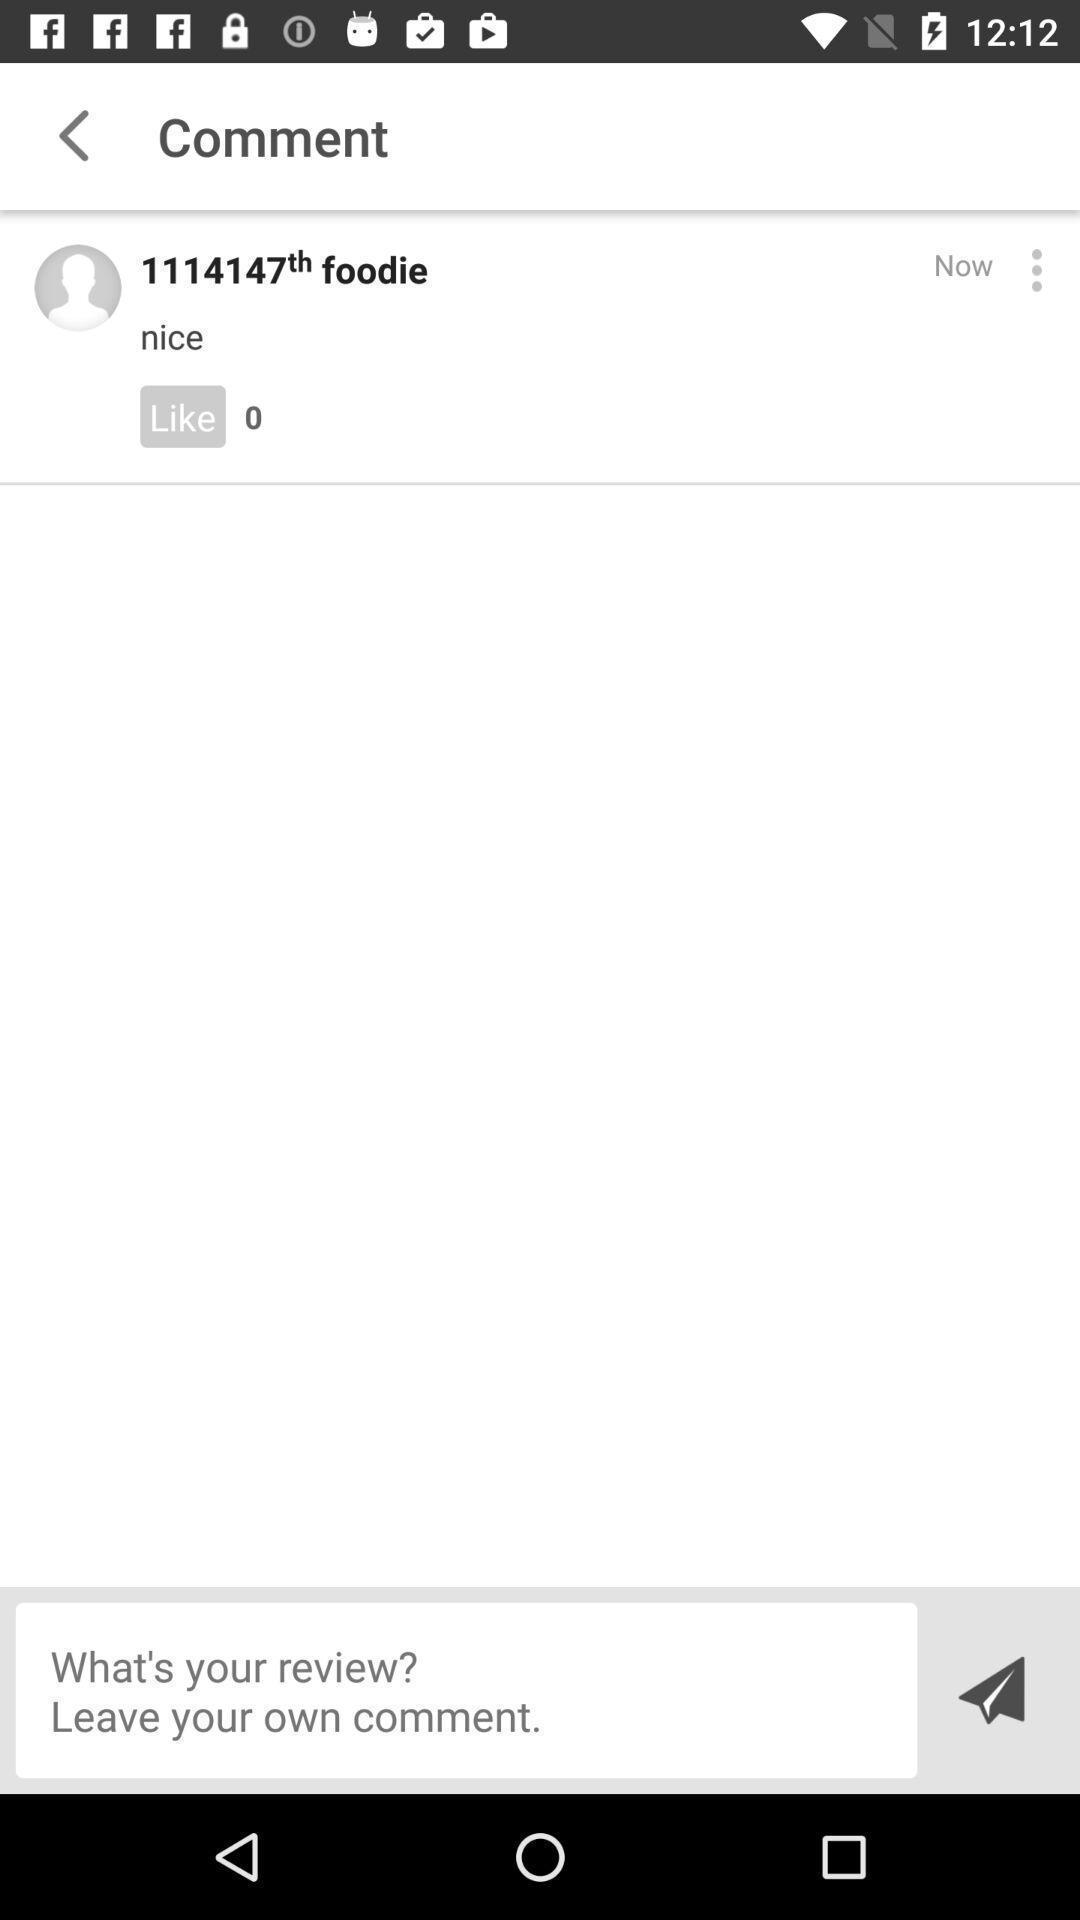Describe this image in words. Screen showing comments. 